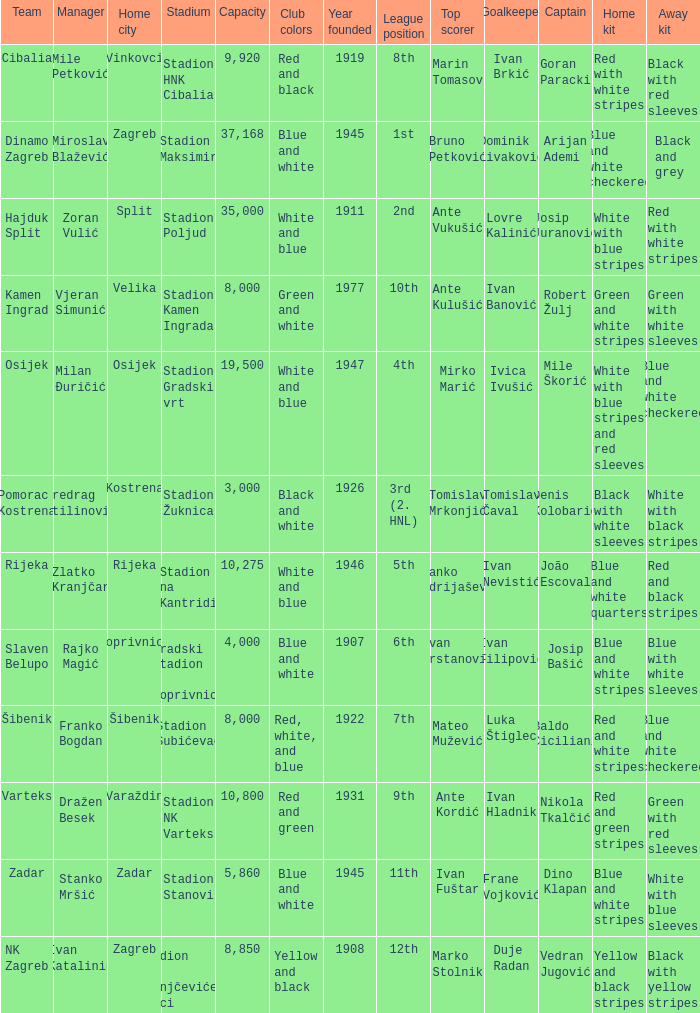What team that has a Home city of Zadar? Zadar. 